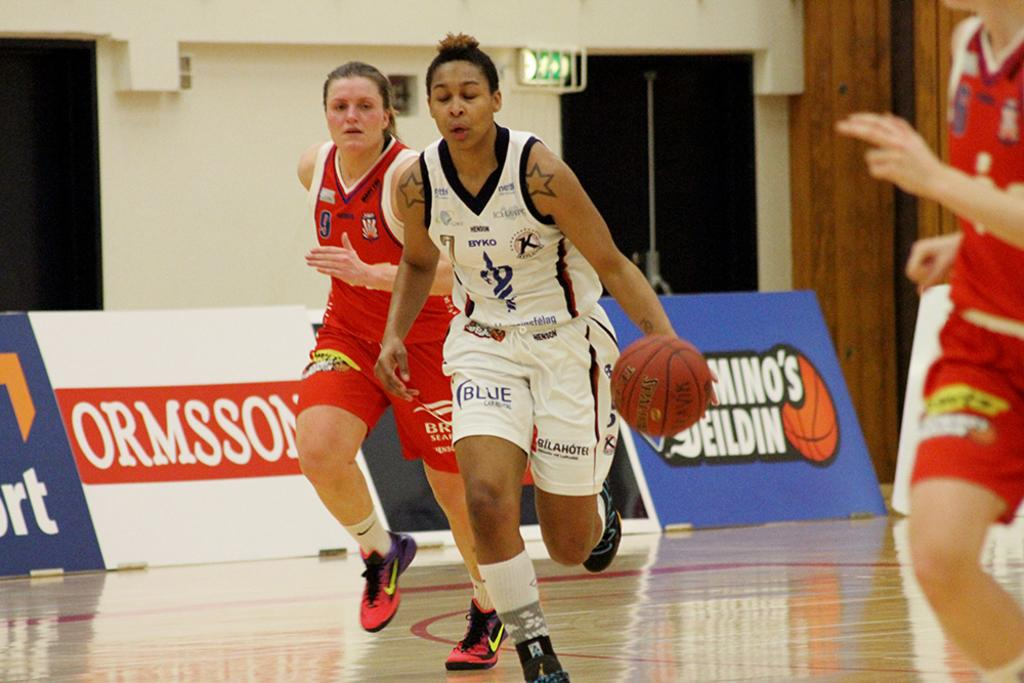<image>
Present a compact description of the photo's key features. A basketball player has the letters BYKO on her jersey. 